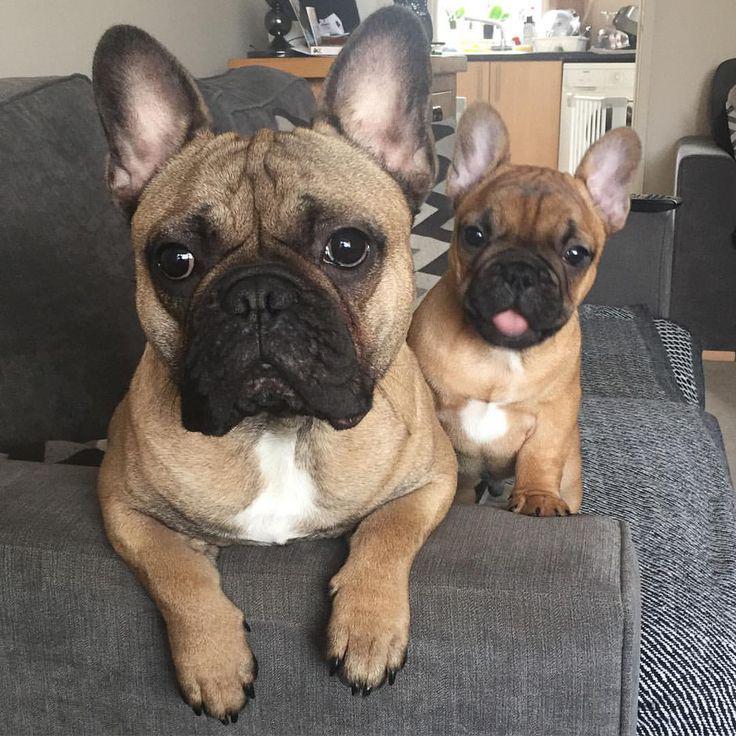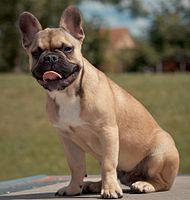The first image is the image on the left, the second image is the image on the right. Evaluate the accuracy of this statement regarding the images: "None of the dogs pictured are wearing collars.". Is it true? Answer yes or no. Yes. The first image is the image on the left, the second image is the image on the right. Considering the images on both sides, is "Each image includes one buff-beige bulldog puppy, and the puppy on the left is sitting on fabric, while the puppy on the right is standing on all fours." valid? Answer yes or no. No. 